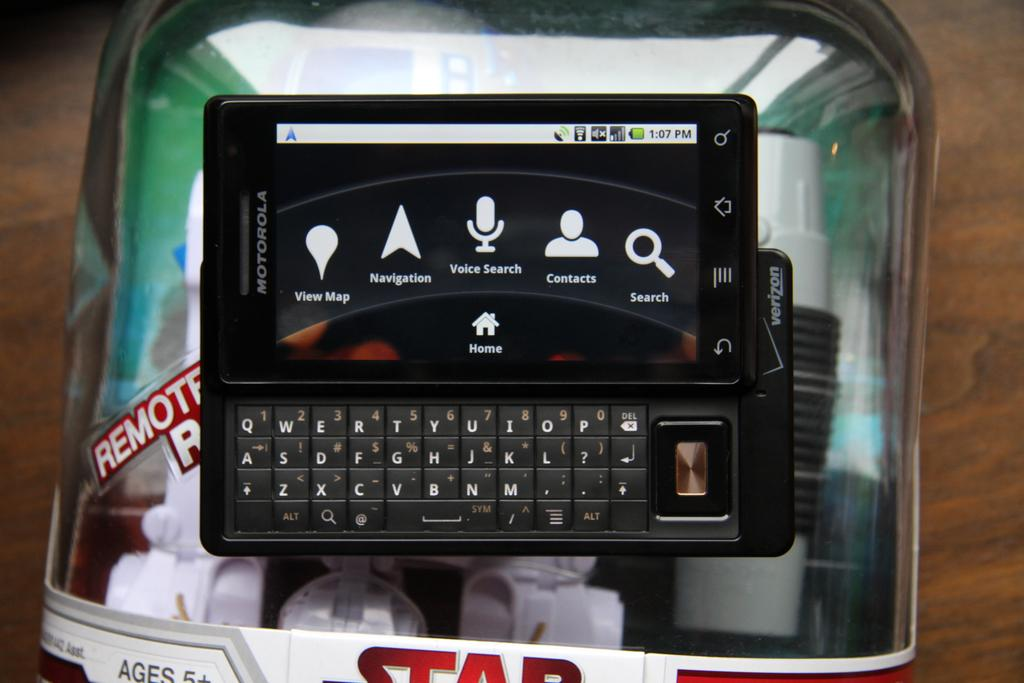What is the main object visible in the image? There is a mobile in the image. What color is the mobile? The mobile is black in color. Where is the mobile located? The mobile is on an object. What is the object on which the mobile is placed? The object is on a table. What is the color of the table? The table is brown in color. Is there a boy holding the mobile in the image? There is no boy present in the image. What type of calendar is visible on the table? There is no calendar present in the image. 